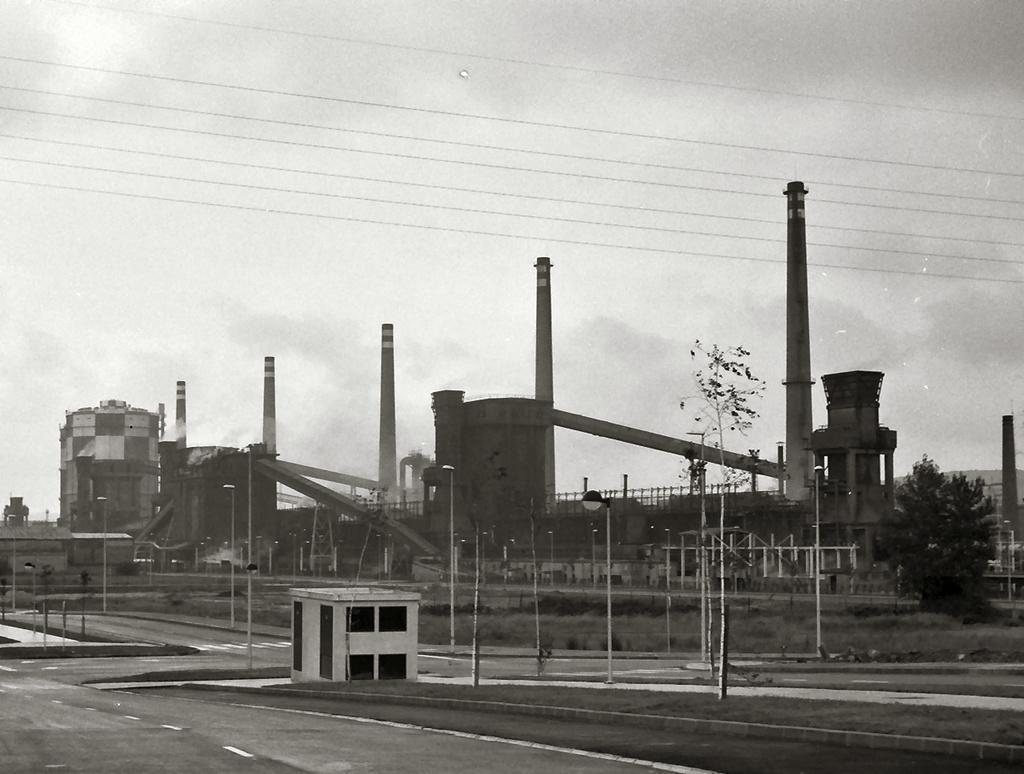Could you give a brief overview of what you see in this image? In this image, there are a few buildings, poles, trees, chimneys. We can see the ground with grass and some objects. We can also see the fence and the sky with clouds. 